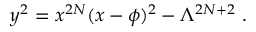<formula> <loc_0><loc_0><loc_500><loc_500>y ^ { 2 } = x ^ { 2 N } ( x - \phi ) ^ { 2 } - \Lambda ^ { 2 N + 2 } \ .</formula> 